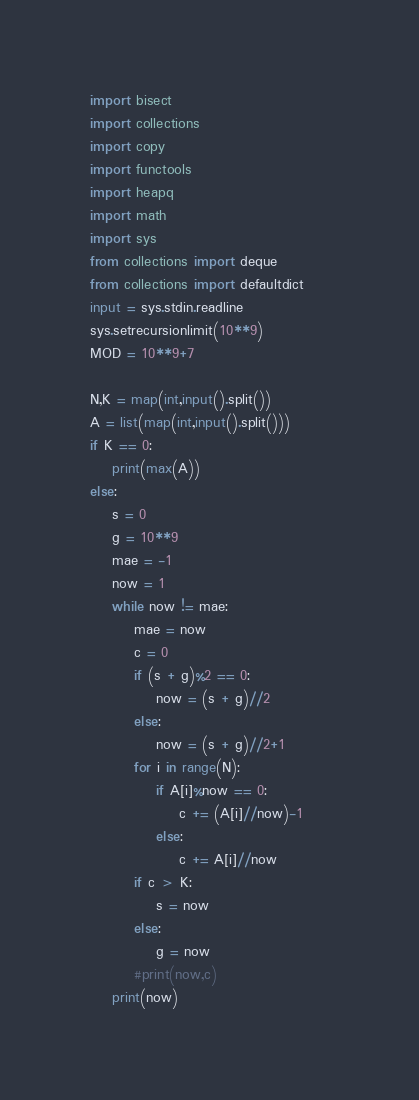Convert code to text. <code><loc_0><loc_0><loc_500><loc_500><_Python_>import bisect
import collections
import copy
import functools
import heapq
import math
import sys
from collections import deque
from collections import defaultdict
input = sys.stdin.readline
sys.setrecursionlimit(10**9)
MOD = 10**9+7

N,K = map(int,input().split())
A = list(map(int,input().split()))
if K == 0:
    print(max(A))
else:
    s = 0
    g = 10**9
    mae = -1
    now = 1
    while now != mae:
        mae = now
        c = 0
        if (s + g)%2 == 0:
            now = (s + g)//2
        else:
            now = (s + g)//2+1        
        for i in range(N):
            if A[i]%now == 0:
                c += (A[i]//now)-1
            else:
                c += A[i]//now
        if c > K:
            s = now
        else:
            g = now
        #print(now,c)
    print(now)</code> 